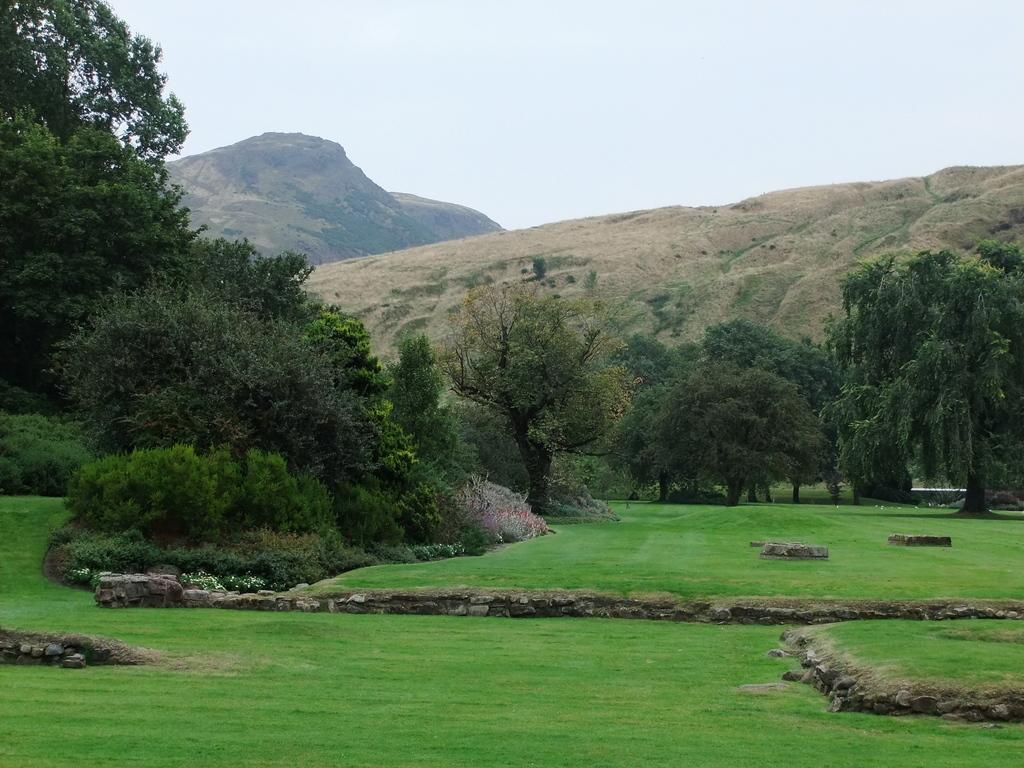What type of vegetation is present in the image? There are trees with branches and leaves in the image. What other natural elements can be seen in the image? Rocks and green grass are visible in the image. What type of landscape feature is present in the image? There are mountains in the image. What part of the natural environment is visible in the image? The sky is visible in the image. How many crows are sitting on the branches of the trees in the image? There are no crows present in the image; it only features trees, rocks, grass, mountains, and the sky. What type of range is visible in the image? There is no specific range mentioned or visible in the image; it simply shows a natural landscape with trees, rocks, grass, mountains, and the sky. 